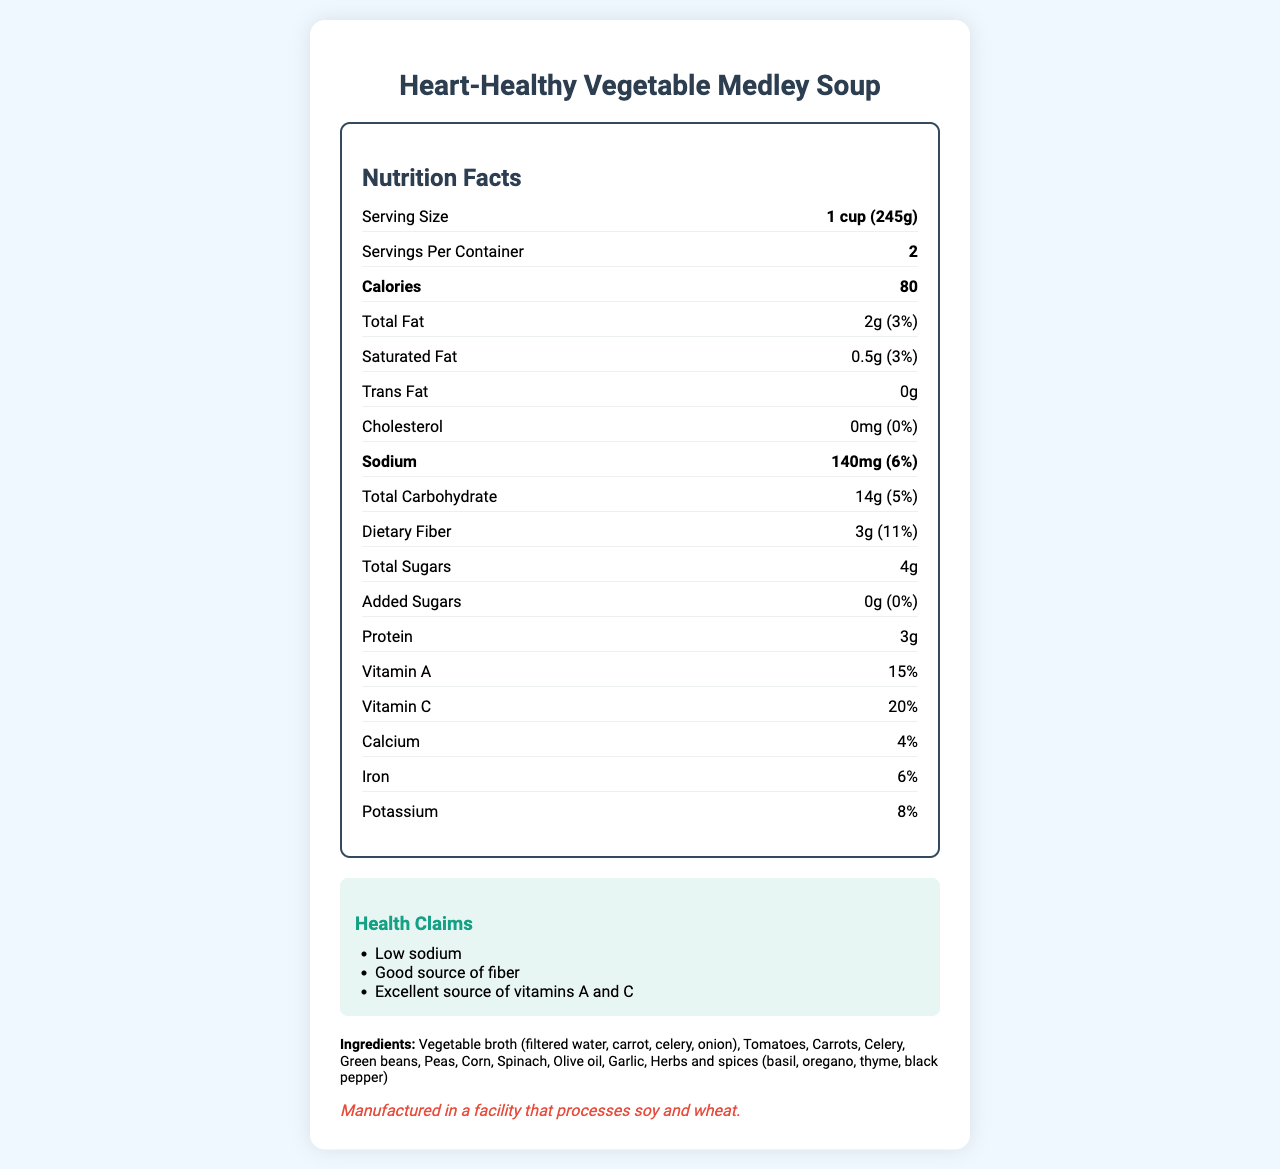what is the sodium content per serving? The nutrition label shows that the sodium content per serving is 140mg.
Answer: 140mg what is the serving size? According to the nutrition label, the serving size is 1 cup (245g).
Answer: 1 cup (245g) how many calories are in one serving? The label indicates that each serving contains 80 calories.
Answer: 80 calories how much total fat is in a container? Each serving contains 2g of total fat and there are 2 servings per container, so 2g * 2 = 4g.
Answer: 4g which vegetable is NOT listed in the ingredients? A. Carrots B. Spinach C. Potatoes D. Tomatoes Carrots, Spinach, and Tomatoes are listed in the ingredients, but Potatoes are not.
Answer: C how many grams of protein does one serving have? The nutrition label states that there are 3 grams of protein per serving.
Answer: 3g True or False: This soup contains added sugars. The nutrition label shows that there are 0g of added sugars.
Answer: False which vitamin is provided the most per serving? A. Vitamin A B. Vitamin C C. Calcium D. Iron Vitamin C is provided at 20% per serving, which is the highest among the listed nutrients.
Answer: B describe the main idea of this nutrition label The label outlines the nutritional content of the soup and highlights its health benefits, focusing on its reduced sodium levels and rich vegetable content.
Answer: The nutrition label provides detailed information about Heart-Healthy Vegetable Medley Soup, including serving size, calories, nutrient amounts, and percentage of daily values. It emphasizes that the soup is low in sodium, a good source of fiber, and an excellent source of vitamins A and C. what is the percentage daily value of dietary fiber in one serving? The nutrition label indicates that one serving contains 11% of the daily value for dietary fiber.
Answer: 11% is this product high in cholesterol? The nutrition label shows that the soup contains 0mg of cholesterol.
Answer: No what type of oil is used in this soup? According to the ingredients list, olive oil is used in the soup.
Answer: Olive oil Can you determine the exact quantities of each vegetable used in the soup? The nutrition label lists the vegetables used in the ingredients but doesn't provide exact quantities.
Answer: Not enough information 